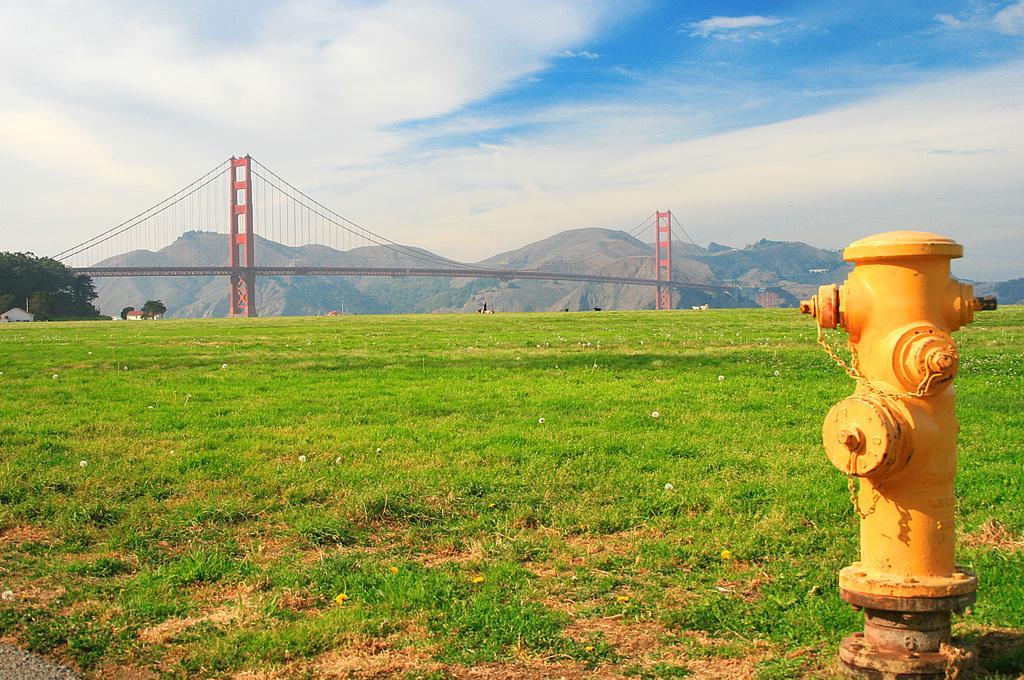Describe this image in one or two sentences. In the picture we can see fire hydrant, there is grass, in the background of the picture we can see bridge, there are some trees, mountain and top of the picture there is clear sky. 